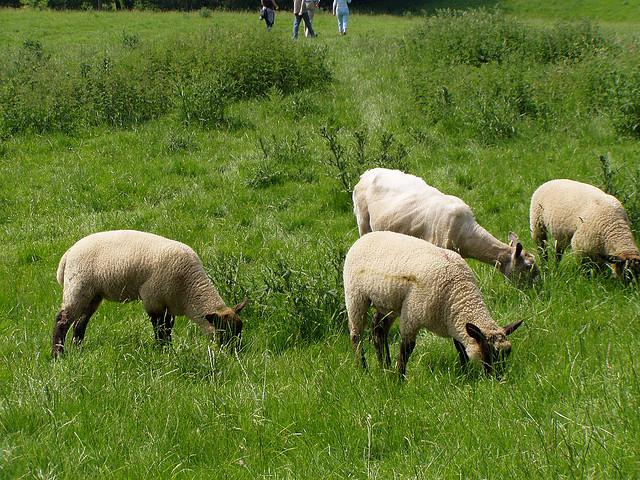How many species are in this image? Please explain your reasoning. two. The distinct species are visible based on their defining characteristics and there are clearly two different ones. 